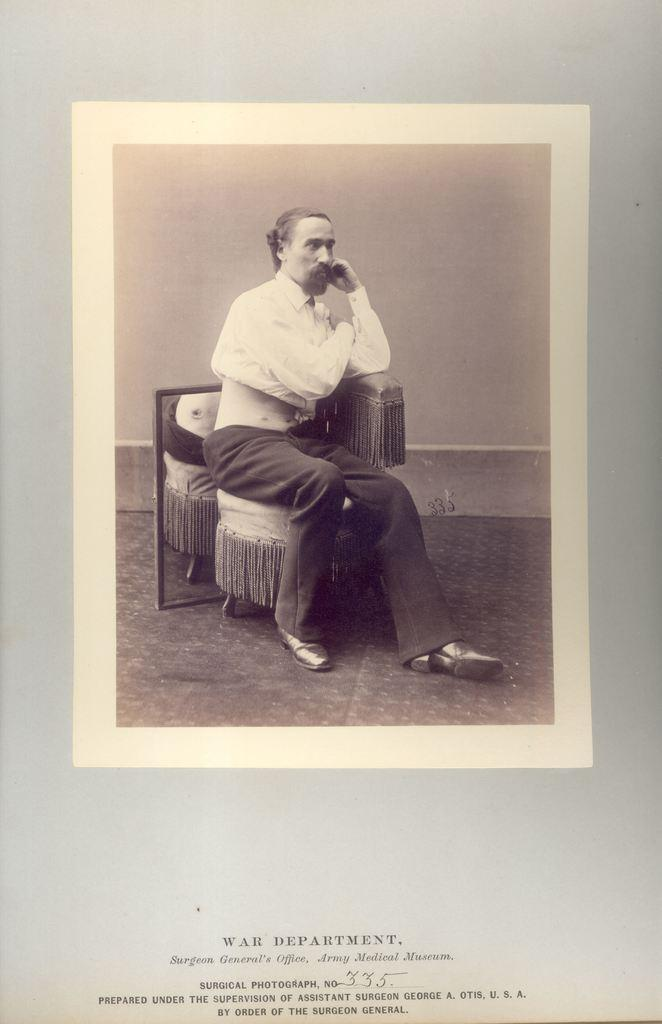What is the person in the image doing? The person is sitting in a chair. Can you describe anything else about the person or their surroundings? Unfortunately, there is not enough information provided to describe the person or their surroundings in more detail. What can be seen at the bottom of the image? There is something written at the bottom of the image. How many lizards are crawling on the engine in the image? There is no engine or lizards present in the image. 